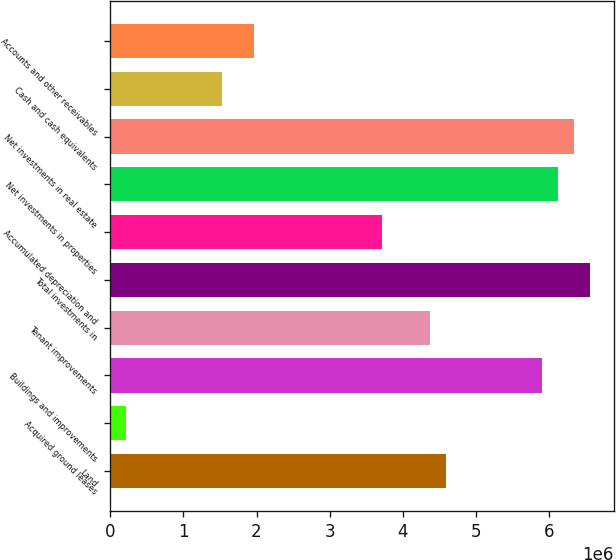<chart> <loc_0><loc_0><loc_500><loc_500><bar_chart><fcel>Land<fcel>Acquired ground leases<fcel>Buildings and improvements<fcel>Tenant improvements<fcel>Total investments in<fcel>Accumulated depreciation and<fcel>Net investments in properties<fcel>Net investments in real estate<fcel>Cash and cash equivalents<fcel>Accounts and other receivables<nl><fcel>4.59046e+06<fcel>219110<fcel>5.90187e+06<fcel>4.3719e+06<fcel>6.55757e+06<fcel>3.71619e+06<fcel>6.12044e+06<fcel>6.33901e+06<fcel>1.53052e+06<fcel>1.96765e+06<nl></chart> 